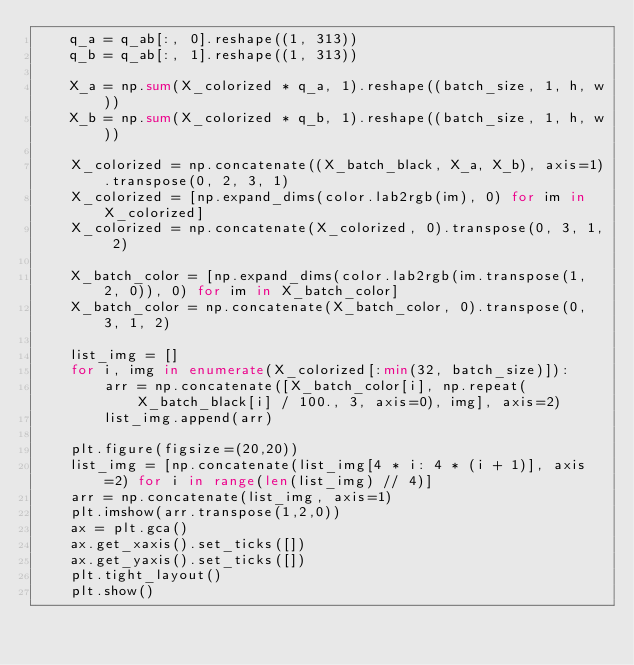Convert code to text. <code><loc_0><loc_0><loc_500><loc_500><_Python_>    q_a = q_ab[:, 0].reshape((1, 313))
    q_b = q_ab[:, 1].reshape((1, 313))

    X_a = np.sum(X_colorized * q_a, 1).reshape((batch_size, 1, h, w))
    X_b = np.sum(X_colorized * q_b, 1).reshape((batch_size, 1, h, w))

    X_colorized = np.concatenate((X_batch_black, X_a, X_b), axis=1).transpose(0, 2, 3, 1)
    X_colorized = [np.expand_dims(color.lab2rgb(im), 0) for im in X_colorized]
    X_colorized = np.concatenate(X_colorized, 0).transpose(0, 3, 1, 2)

    X_batch_color = [np.expand_dims(color.lab2rgb(im.transpose(1, 2, 0)), 0) for im in X_batch_color]
    X_batch_color = np.concatenate(X_batch_color, 0).transpose(0, 3, 1, 2)

    list_img = []
    for i, img in enumerate(X_colorized[:min(32, batch_size)]):
        arr = np.concatenate([X_batch_color[i], np.repeat(X_batch_black[i] / 100., 3, axis=0), img], axis=2)
        list_img.append(arr)

    plt.figure(figsize=(20,20))
    list_img = [np.concatenate(list_img[4 * i: 4 * (i + 1)], axis=2) for i in range(len(list_img) // 4)]
    arr = np.concatenate(list_img, axis=1)
    plt.imshow(arr.transpose(1,2,0))
    ax = plt.gca()
    ax.get_xaxis().set_ticks([])
    ax.get_yaxis().set_ticks([])
    plt.tight_layout()
    plt.show()
</code> 